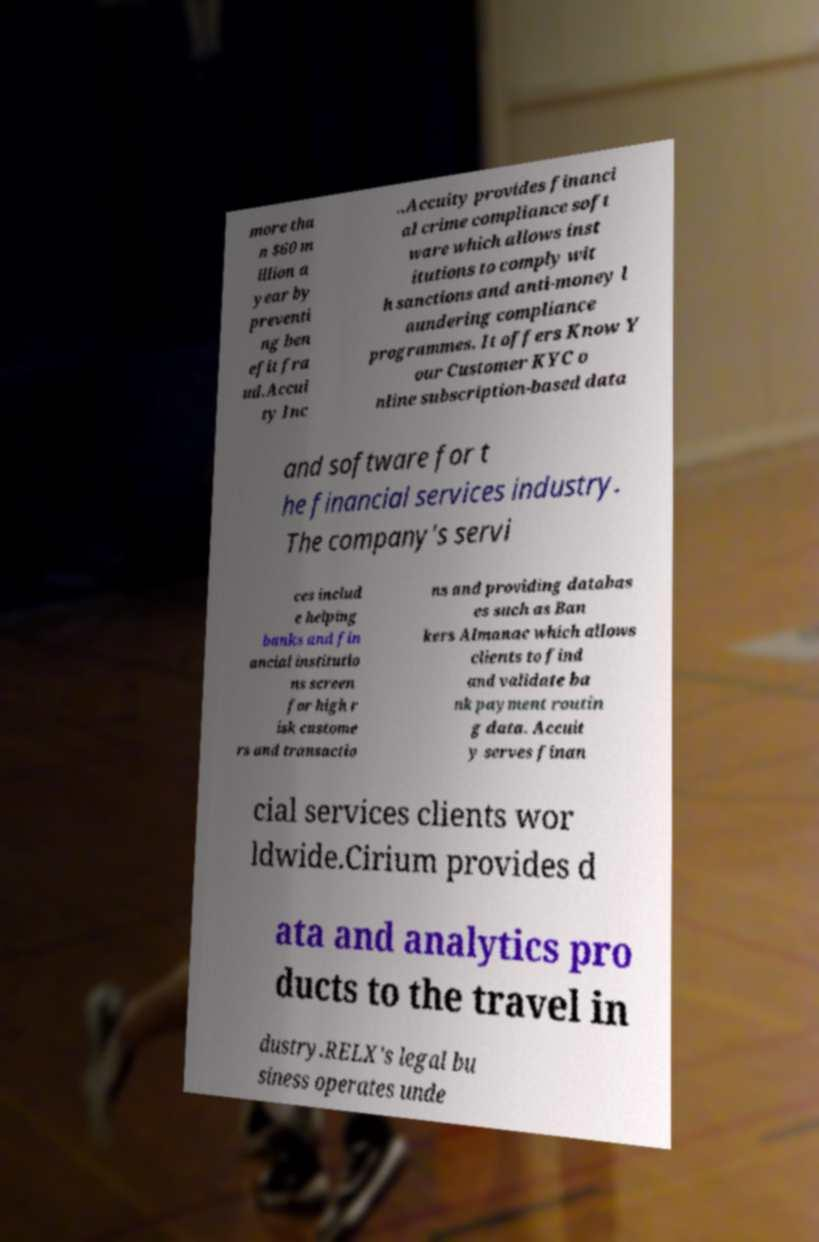Please identify and transcribe the text found in this image. more tha n $60 m illion a year by preventi ng ben efit fra ud.Accui ty Inc ..Accuity provides financi al crime compliance soft ware which allows inst itutions to comply wit h sanctions and anti-money l aundering compliance programmes. It offers Know Y our Customer KYC o nline subscription-based data and software for t he financial services industry. The company's servi ces includ e helping banks and fin ancial institutio ns screen for high r isk custome rs and transactio ns and providing databas es such as Ban kers Almanac which allows clients to find and validate ba nk payment routin g data. Accuit y serves finan cial services clients wor ldwide.Cirium provides d ata and analytics pro ducts to the travel in dustry.RELX's legal bu siness operates unde 